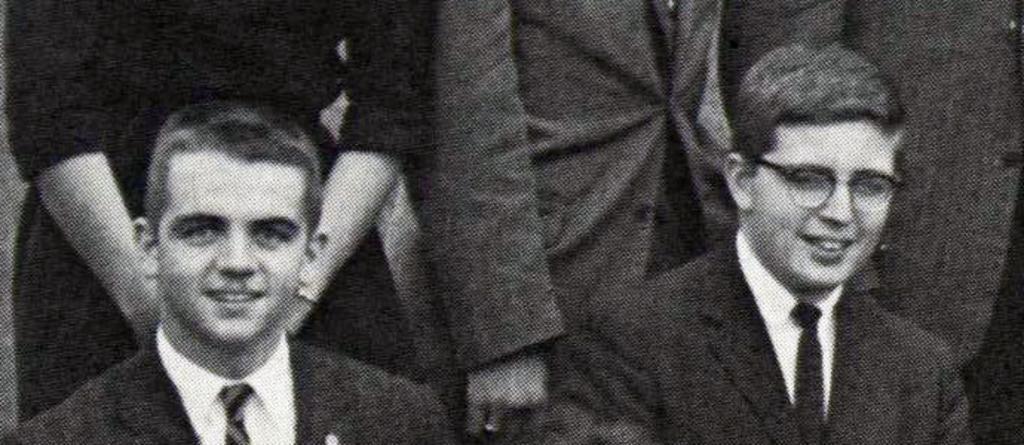Can you describe this image briefly? This image is a black and white image as we can see there are two persons in the bottom of this image and there are some persons standing in the background. 